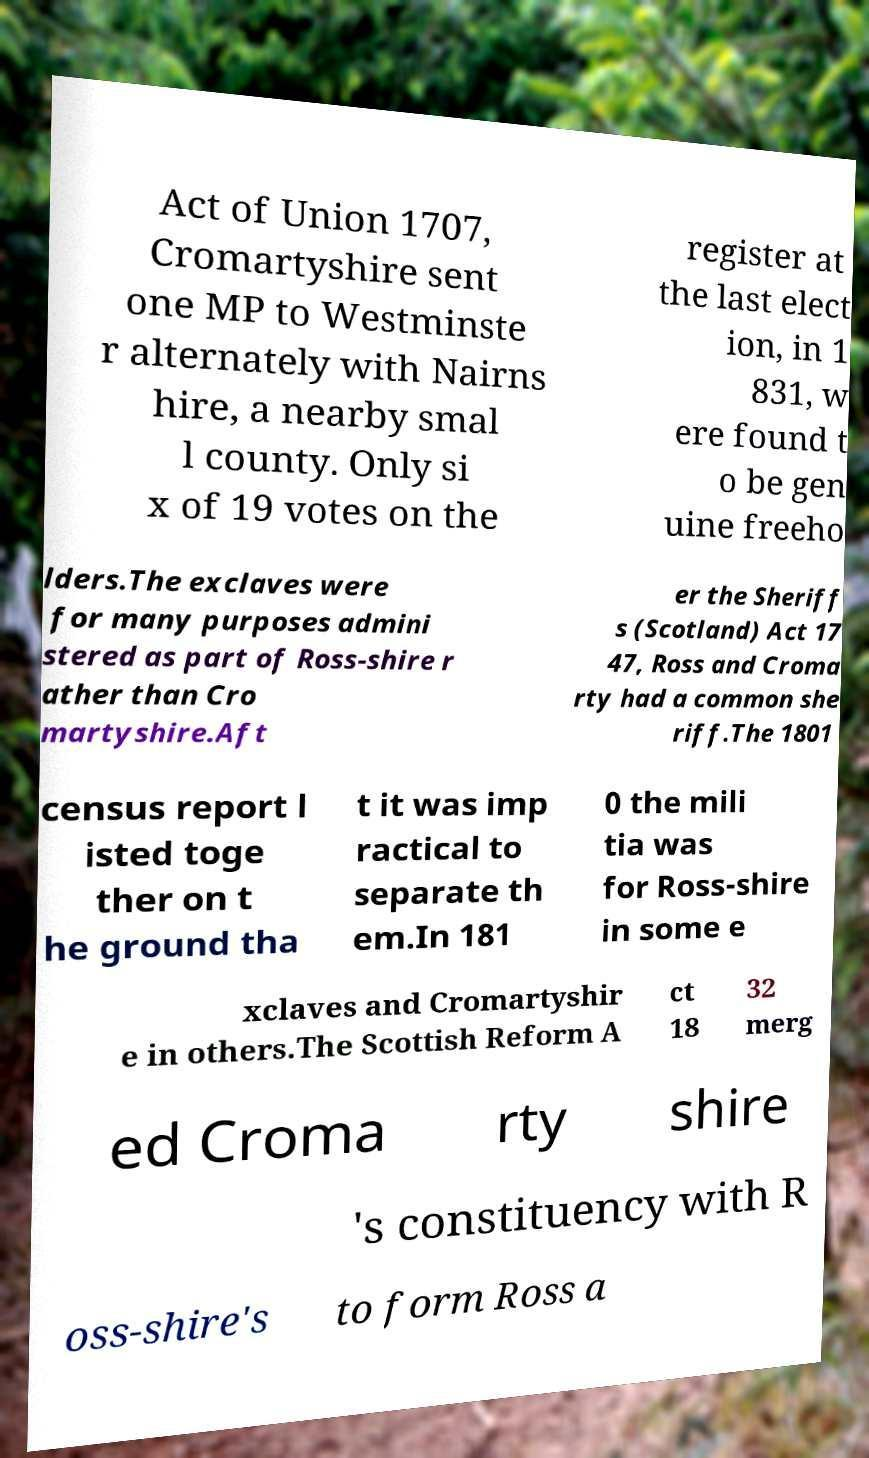Please identify and transcribe the text found in this image. Act of Union 1707, Cromartyshire sent one MP to Westminste r alternately with Nairns hire, a nearby smal l county. Only si x of 19 votes on the register at the last elect ion, in 1 831, w ere found t o be gen uine freeho lders.The exclaves were for many purposes admini stered as part of Ross-shire r ather than Cro martyshire.Aft er the Sheriff s (Scotland) Act 17 47, Ross and Croma rty had a common she riff.The 1801 census report l isted toge ther on t he ground tha t it was imp ractical to separate th em.In 181 0 the mili tia was for Ross-shire in some e xclaves and Cromartyshir e in others.The Scottish Reform A ct 18 32 merg ed Croma rty shire 's constituency with R oss-shire's to form Ross a 